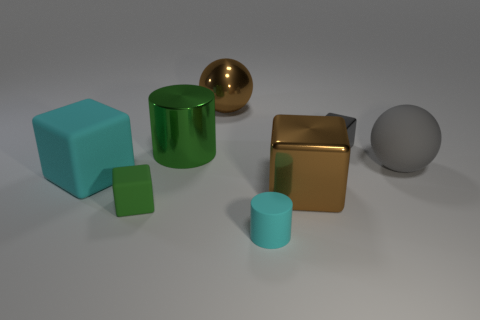Add 1 red cubes. How many objects exist? 9 Subtract all cylinders. How many objects are left? 6 Add 6 small rubber cubes. How many small rubber cubes exist? 7 Subtract 0 red cubes. How many objects are left? 8 Subtract all big gray shiny objects. Subtract all tiny gray objects. How many objects are left? 7 Add 4 gray metal things. How many gray metal things are left? 5 